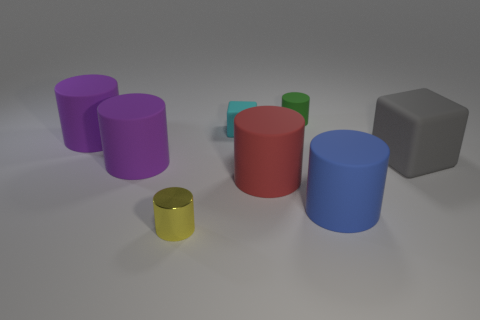Subtract all brown blocks. How many purple cylinders are left? 2 Subtract all green cylinders. How many cylinders are left? 5 Subtract all red cylinders. How many cylinders are left? 5 Add 1 big yellow cylinders. How many objects exist? 9 Subtract all red cylinders. Subtract all blue cubes. How many cylinders are left? 5 Subtract all blocks. How many objects are left? 6 Add 6 tiny yellow rubber balls. How many tiny yellow rubber balls exist? 6 Subtract 0 blue spheres. How many objects are left? 8 Subtract all purple things. Subtract all metal things. How many objects are left? 5 Add 1 cyan matte blocks. How many cyan matte blocks are left? 2 